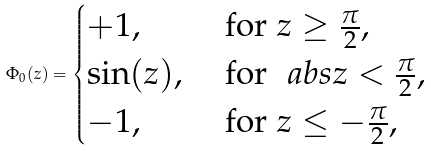<formula> <loc_0><loc_0><loc_500><loc_500>\Phi _ { 0 } ( z ) = \begin{cases} + 1 , & \text { for } z \geq \frac { \pi } { 2 } , \\ \sin ( z ) , & \text { for } \ a b s { z } < \frac { \pi } { 2 } , \\ - 1 , & \text { for } z \leq - \frac { \pi } { 2 } , \end{cases}</formula> 